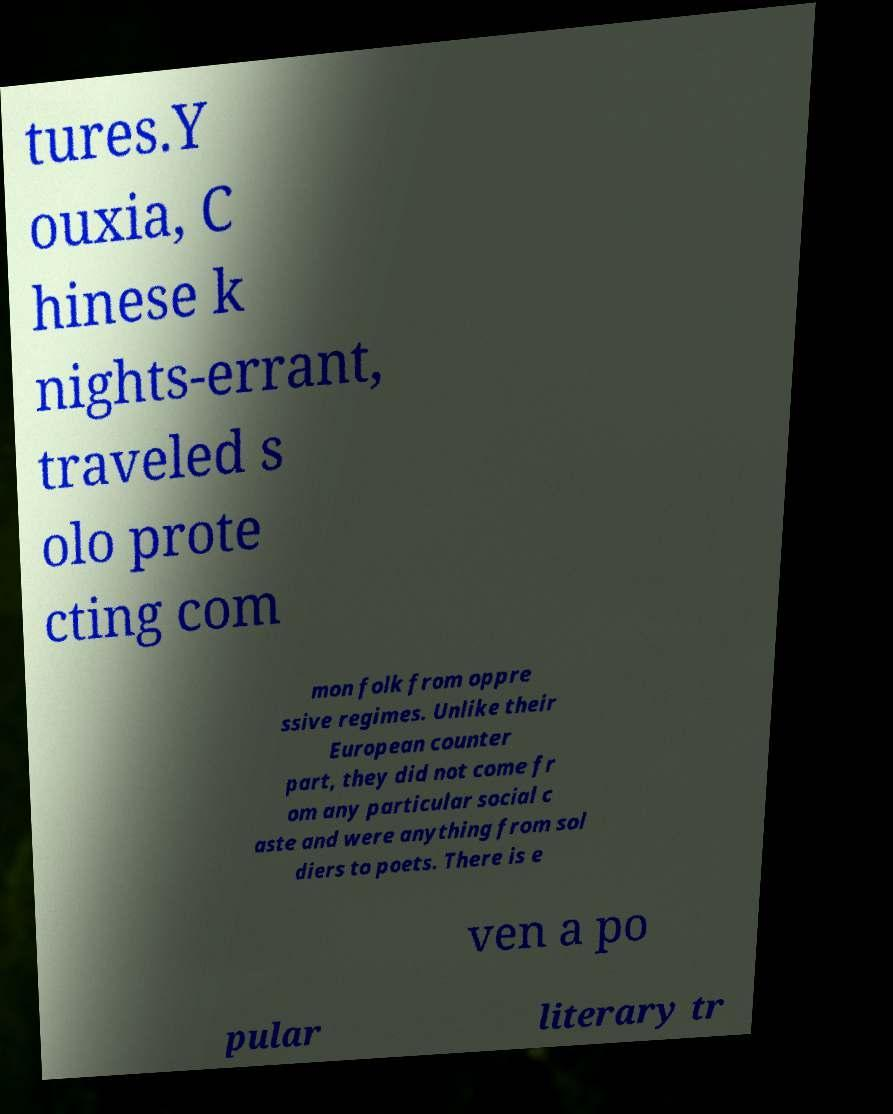Can you accurately transcribe the text from the provided image for me? tures.Y ouxia, C hinese k nights-errant, traveled s olo prote cting com mon folk from oppre ssive regimes. Unlike their European counter part, they did not come fr om any particular social c aste and were anything from sol diers to poets. There is e ven a po pular literary tr 